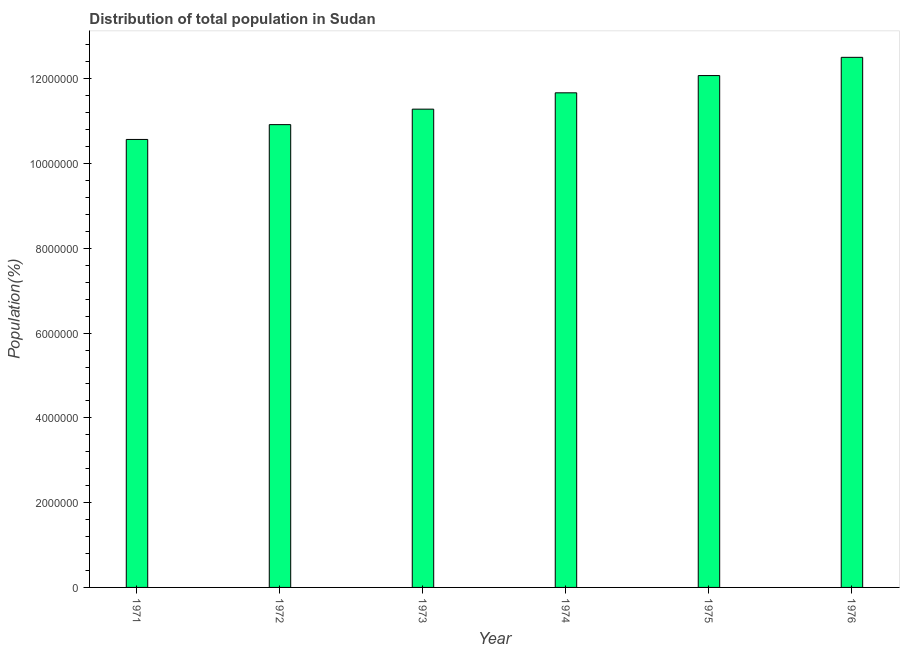Does the graph contain any zero values?
Give a very brief answer. No. Does the graph contain grids?
Ensure brevity in your answer.  No. What is the title of the graph?
Your answer should be compact. Distribution of total population in Sudan . What is the label or title of the X-axis?
Offer a very short reply. Year. What is the label or title of the Y-axis?
Offer a terse response. Population(%). What is the population in 1973?
Keep it short and to the point. 1.13e+07. Across all years, what is the maximum population?
Give a very brief answer. 1.25e+07. Across all years, what is the minimum population?
Offer a very short reply. 1.06e+07. In which year was the population maximum?
Keep it short and to the point. 1976. In which year was the population minimum?
Keep it short and to the point. 1971. What is the sum of the population?
Keep it short and to the point. 6.90e+07. What is the difference between the population in 1972 and 1975?
Keep it short and to the point. -1.16e+06. What is the average population per year?
Give a very brief answer. 1.15e+07. What is the median population?
Make the answer very short. 1.15e+07. What is the ratio of the population in 1973 to that in 1974?
Offer a very short reply. 0.97. Is the population in 1971 less than that in 1976?
Provide a succinct answer. Yes. What is the difference between the highest and the second highest population?
Your answer should be compact. 4.30e+05. Is the sum of the population in 1975 and 1976 greater than the maximum population across all years?
Provide a short and direct response. Yes. What is the difference between the highest and the lowest population?
Provide a succinct answer. 1.94e+06. How many bars are there?
Your response must be concise. 6. What is the Population(%) of 1971?
Your answer should be compact. 1.06e+07. What is the Population(%) of 1972?
Your answer should be compact. 1.09e+07. What is the Population(%) of 1973?
Your answer should be very brief. 1.13e+07. What is the Population(%) of 1974?
Keep it short and to the point. 1.17e+07. What is the Population(%) of 1975?
Make the answer very short. 1.21e+07. What is the Population(%) of 1976?
Your response must be concise. 1.25e+07. What is the difference between the Population(%) in 1971 and 1972?
Keep it short and to the point. -3.49e+05. What is the difference between the Population(%) in 1971 and 1973?
Offer a terse response. -7.15e+05. What is the difference between the Population(%) in 1971 and 1974?
Ensure brevity in your answer.  -1.10e+06. What is the difference between the Population(%) in 1971 and 1975?
Ensure brevity in your answer.  -1.51e+06. What is the difference between the Population(%) in 1971 and 1976?
Offer a terse response. -1.94e+06. What is the difference between the Population(%) in 1972 and 1973?
Give a very brief answer. -3.65e+05. What is the difference between the Population(%) in 1972 and 1974?
Your response must be concise. -7.51e+05. What is the difference between the Population(%) in 1972 and 1975?
Offer a very short reply. -1.16e+06. What is the difference between the Population(%) in 1972 and 1976?
Your answer should be very brief. -1.59e+06. What is the difference between the Population(%) in 1973 and 1974?
Provide a short and direct response. -3.85e+05. What is the difference between the Population(%) in 1973 and 1975?
Keep it short and to the point. -7.92e+05. What is the difference between the Population(%) in 1973 and 1976?
Your response must be concise. -1.22e+06. What is the difference between the Population(%) in 1974 and 1975?
Provide a short and direct response. -4.07e+05. What is the difference between the Population(%) in 1974 and 1976?
Offer a terse response. -8.37e+05. What is the difference between the Population(%) in 1975 and 1976?
Your response must be concise. -4.30e+05. What is the ratio of the Population(%) in 1971 to that in 1973?
Offer a very short reply. 0.94. What is the ratio of the Population(%) in 1971 to that in 1974?
Provide a short and direct response. 0.91. What is the ratio of the Population(%) in 1971 to that in 1976?
Keep it short and to the point. 0.84. What is the ratio of the Population(%) in 1972 to that in 1974?
Offer a very short reply. 0.94. What is the ratio of the Population(%) in 1972 to that in 1975?
Your answer should be very brief. 0.9. What is the ratio of the Population(%) in 1972 to that in 1976?
Offer a terse response. 0.87. What is the ratio of the Population(%) in 1973 to that in 1975?
Keep it short and to the point. 0.93. What is the ratio of the Population(%) in 1973 to that in 1976?
Offer a terse response. 0.9. What is the ratio of the Population(%) in 1974 to that in 1976?
Offer a terse response. 0.93. 